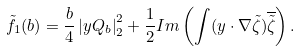Convert formula to latex. <formula><loc_0><loc_0><loc_500><loc_500>\tilde { f _ { 1 } } ( b ) = \frac { b } { 4 } \left | y Q _ { b } \right | _ { 2 } ^ { 2 } + \frac { 1 } { 2 } I m \left ( \int ( y \cdot \nabla \tilde { \zeta } ) \overline { \tilde { \zeta } } \right ) .</formula> 